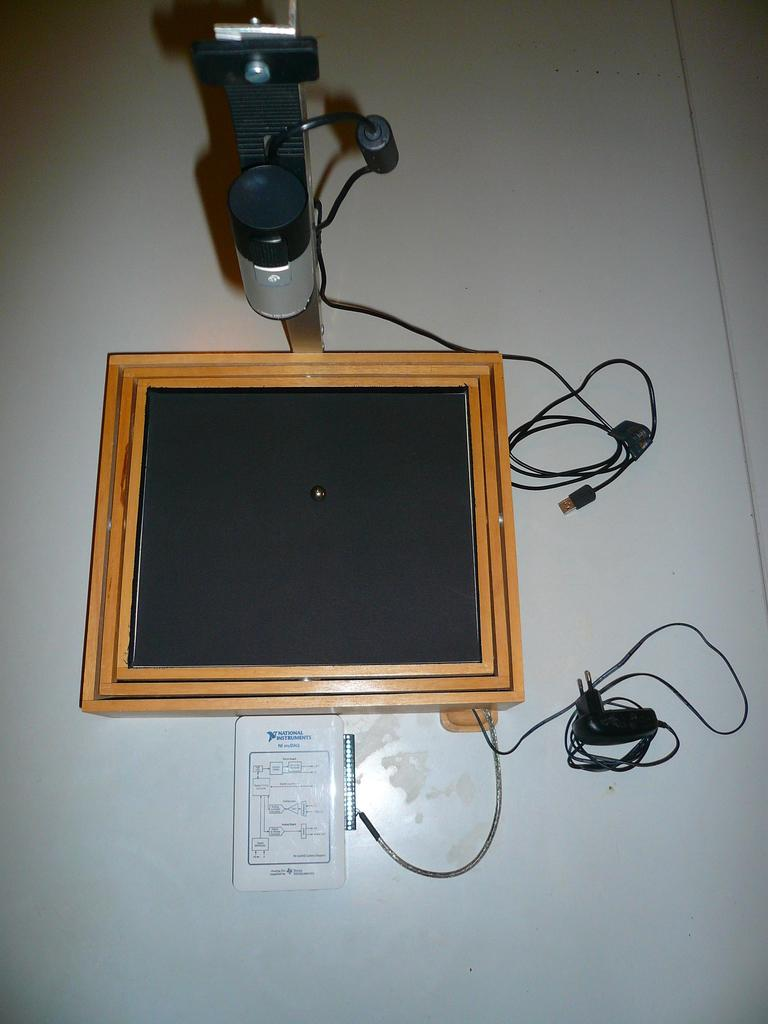What is the main object in the image? There is an object in the image, but its specific nature is not mentioned in the facts. What color is the object in the image? The object is black in color. What else can be seen in the image besides the object? There are wires in the image. What is the color of the surface on which the wires are placed? The wires are placed on a white surface. How many quarters can be seen in the image? There is no mention of quarters in the image, so it is not possible to determine their presence or quantity. 